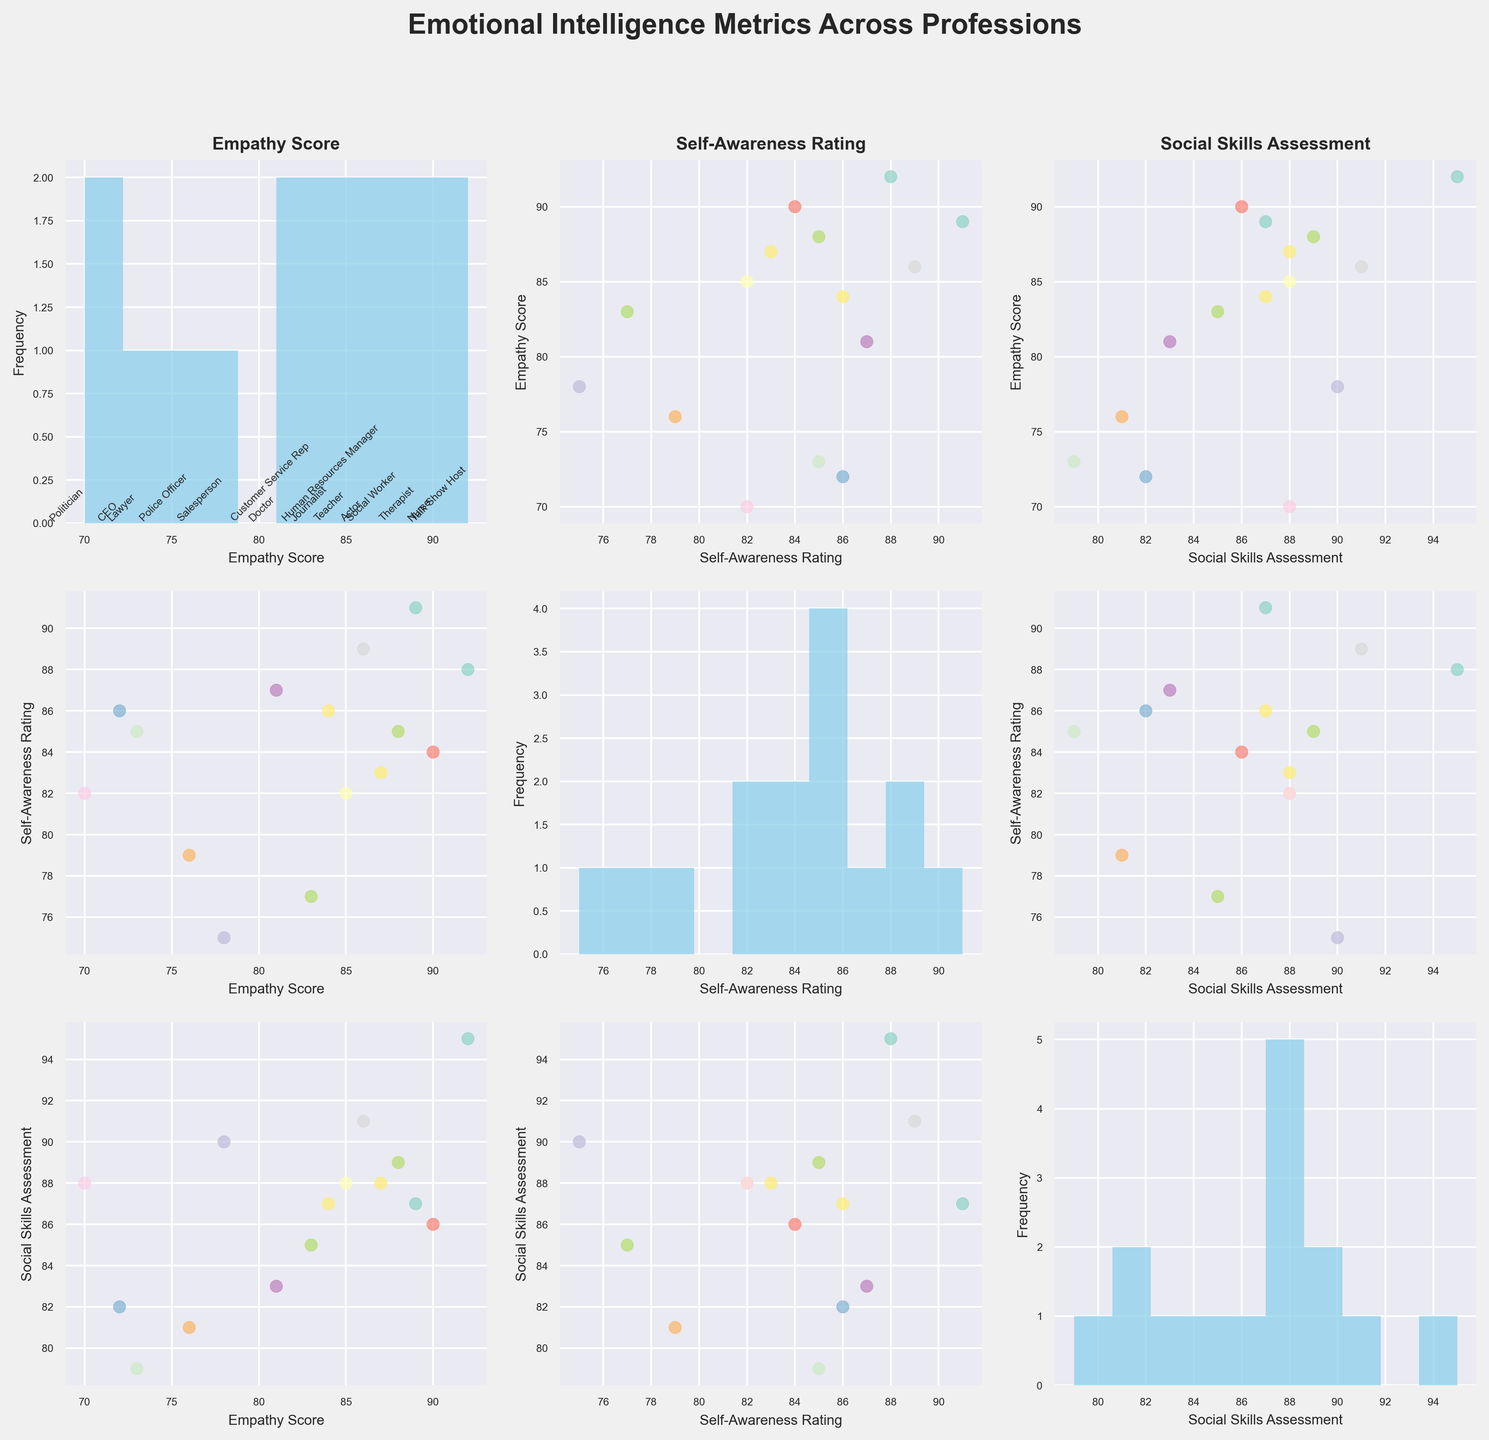What's the title of the figure? The title of the figure can be seen at the top of the plot.
Answer: Emotional Intelligence Metrics Across Professions How many professions are represented in the plot? The number of professions can be determined by counting the annotations in the scatterplot or the data points within the histograms.
Answer: 15 Which profession has the highest empathy score? By looking at the scatterplot for 'Empathy Score', the profession with the highest point value on the corresponding axis is identifiable.
Answer: Talk Show Host What is the common characteristic of professions with empathy scores higher than 85? By examining scatterplots, we can identify the empathy scores above 85, and then cross-reference those professions' other metrics.
Answer: They tend to also have high social skills and self-awareness ratings How does the 'Self-Awareness Rating' of teachers compare to that of social workers? Looking at the scatterplots for 'Self-Awareness Rating' and finding the respective points for teachers and social workers help in directly comparing the two values.
Answer: Social workers have a higher self-awareness rating than teachers Which profession has the lowest social skills assessment? By looking at the scatterplot for 'Social Skills Assessment', the profession with the lowest point value on the corresponding axis is identifiable.
Answer: Lawyer Is there a profession with a higher empathy score than social skills assessment? If so, which? By comparing the 'Empathy Score' and 'Social Skills Assessment' for each profession, we identify if any profession has a higher value in empathy than in social skills.
Answer: Yes, Doctor Do any professions have the same value for empathy scores and self-awareness ratings? Comparing both the 'Empathy Score' and 'Self-Awareness Rating' scatterplots, we can check if any points align on the equal values for both axes.
Answer: No Based on the histograms, which assessment has the greatest variability? By comparing the distributions in the histograms for 'Empathy Score', 'Self-Awareness Rating', and 'Social Skills Assessment', we determine which has the widest spread.
Answer: Self-Awareness Rating What's the average empathy score of professions with social skills assessment higher than 85? First identify the professions with social skills assessment above 85. Then, sum their empathy scores and divide by the number of those professions.
Answer: (Sum of empathy scores for professions with social skills > 85) / (Number of such professions) [89 + 85 + 78 + 88 + 87 + 86 + 84 + 92]/8 = 85.5 